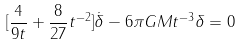<formula> <loc_0><loc_0><loc_500><loc_500>[ \frac { 4 } { 9 t } + \frac { 8 } { 2 7 } t ^ { - 2 } ] \dot { \delta } - 6 { \pi } G M t ^ { - 3 } { \delta } = 0</formula> 